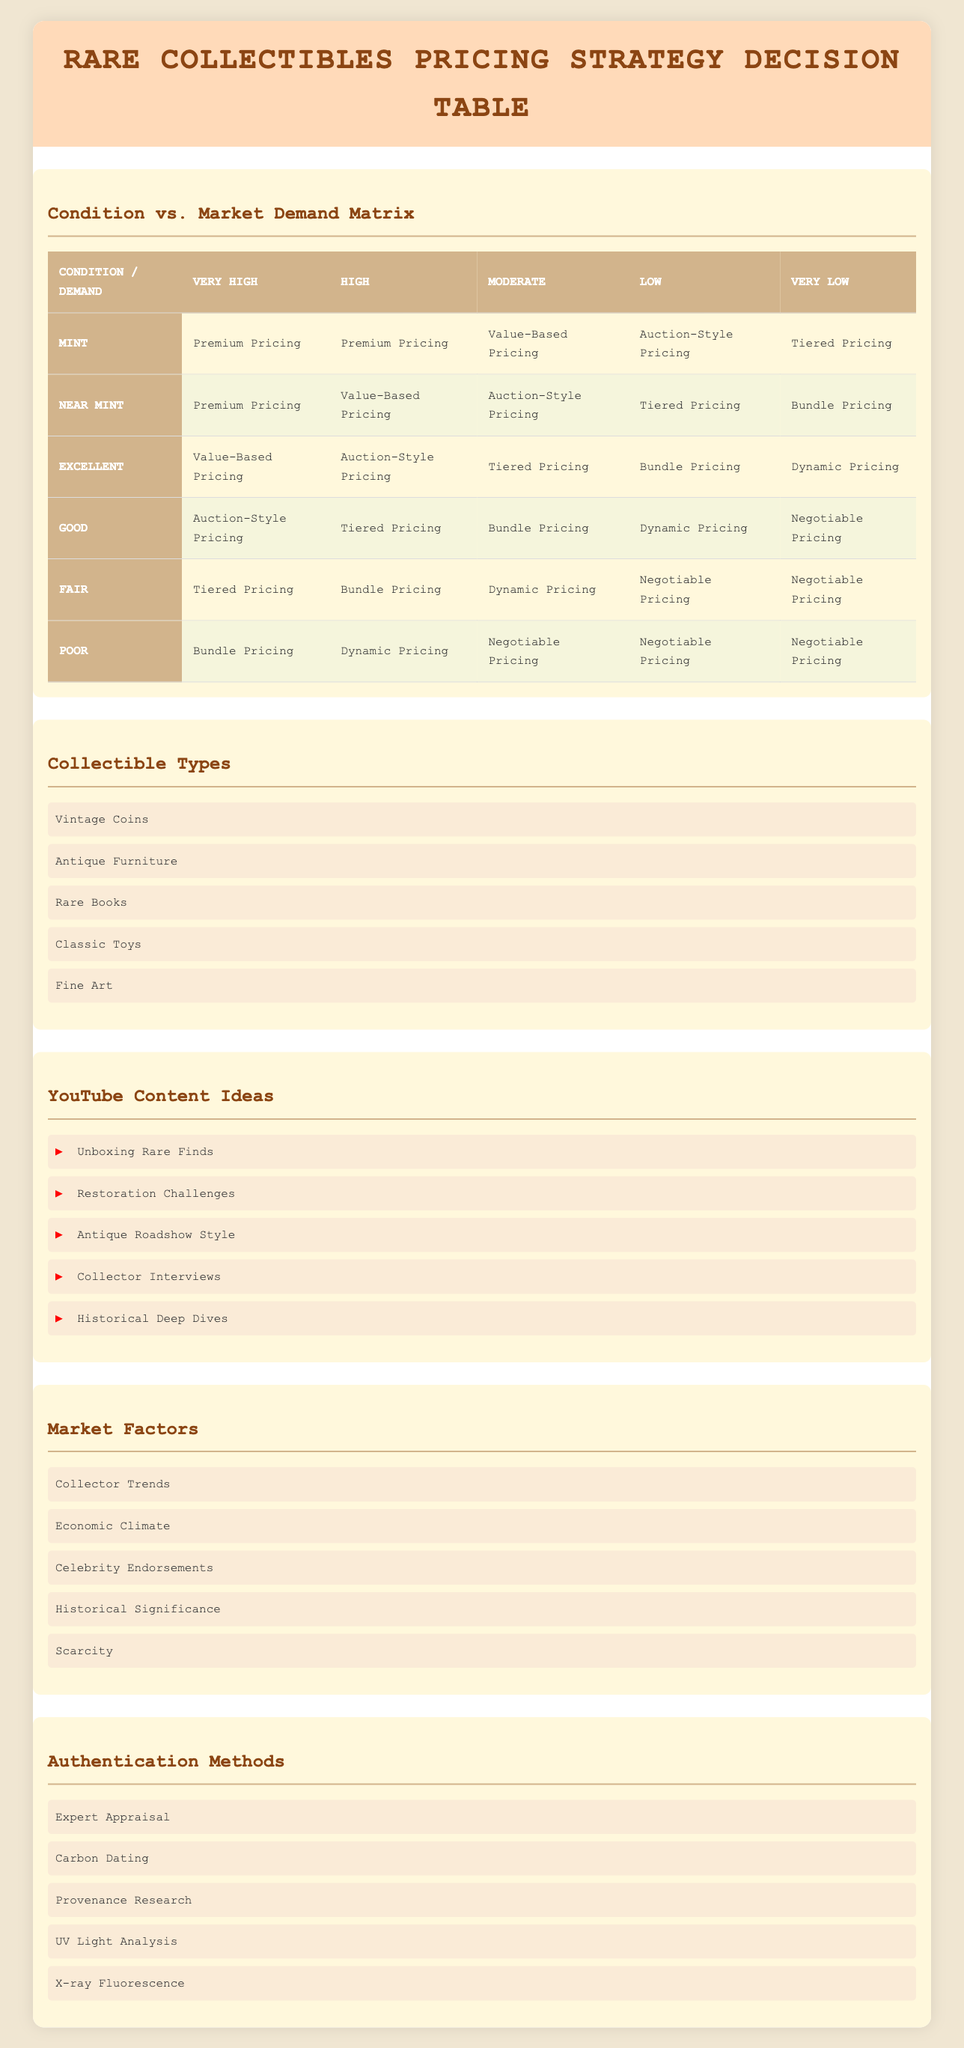What pricing strategy is recommended for Mint condition collectibles with Very High market demand? The table indicates that the recommended pricing strategy for Mint condition collectibles when market demand is Very High is Premium Pricing.
Answer: Premium Pricing What is the pricing strategy for Poor condition collectibles with Moderate market demand? According to the table, the pricing strategy for Poor condition collectibles with Moderate market demand is Negotiable Pricing.
Answer: Negotiable Pricing Is Value-Based Pricing ever recommended for collectibles in Excellent condition? Yes, Value-Based Pricing is recommended for Excellent condition collectibles when the market demand is Moderate, and it is also the strategy for Very High demand in case of Near Mint condition.
Answer: Yes For Near Mint condition collectibles, what is the pricing strategy with Low market demand? The pricing strategy for Near Mint condition collectibles with Low market demand, as per the table, is Tiered Pricing.
Answer: Tiered Pricing Could you calculate the total number of unique pricing strategies recommended for Mint condition collectibles across all market demands? The recommended strategies for Mint condition collectibles are: Premium Pricing (2), Value-Based Pricing (1), Auction-Style Pricing (1), and Tiered Pricing (1). The total is 5 unique pricing strategies observed across the demand categories Very High, High, Moderate, Low, and Very Low.
Answer: 5 What is the difference in pricing strategies between collectibles in Fair and Good condition when market demand is Low? For Fair condition collectibles, the strategy is Negotiable Pricing, while for Good condition collectibles, it is Dynamic Pricing. The difference is that Fair has Negotiable Pricing and Good has Dynamic Pricing.
Answer: Negotiable Pricing vs. Dynamic Pricing Are there more collectible types with a Premium Pricing strategy than those with a Bundle Pricing strategy? Based on the table, Premium Pricing appears for Mint and Near Mint conditions. Bundle Pricing is used for Fair and Poor conditions. Analysis shows Premium Pricing is recommended for 3 unique conditions while Bundle Pricing is for 3 conditions, making it equal.
Answer: No Which condition and market demand combination has the most diverse pricing strategies? Examining the table, the condition Good with Very High demand has Auction-Style Pricing, which has different recommended strategies compared to other conditions. Overall, the most diverse strategies can be found in the Mint condition category since it has five unique strategies as compared to Good or others.
Answer: Mint condition with Very High demand 